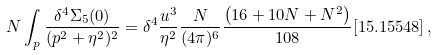<formula> <loc_0><loc_0><loc_500><loc_500>N \int _ { p } \frac { \delta ^ { 4 } \Sigma _ { 5 } ( 0 ) } { ( p ^ { 2 } + \eta ^ { 2 } ) ^ { 2 } } = \delta ^ { 4 } \frac { u ^ { 3 } } { \eta ^ { 2 } } \frac { N } { ( 4 \pi ) ^ { 6 } } \frac { \left ( 1 6 + 1 0 N + N ^ { 2 } \right ) } { 1 0 8 } [ 1 5 . 1 5 5 4 8 ] \, ,</formula> 